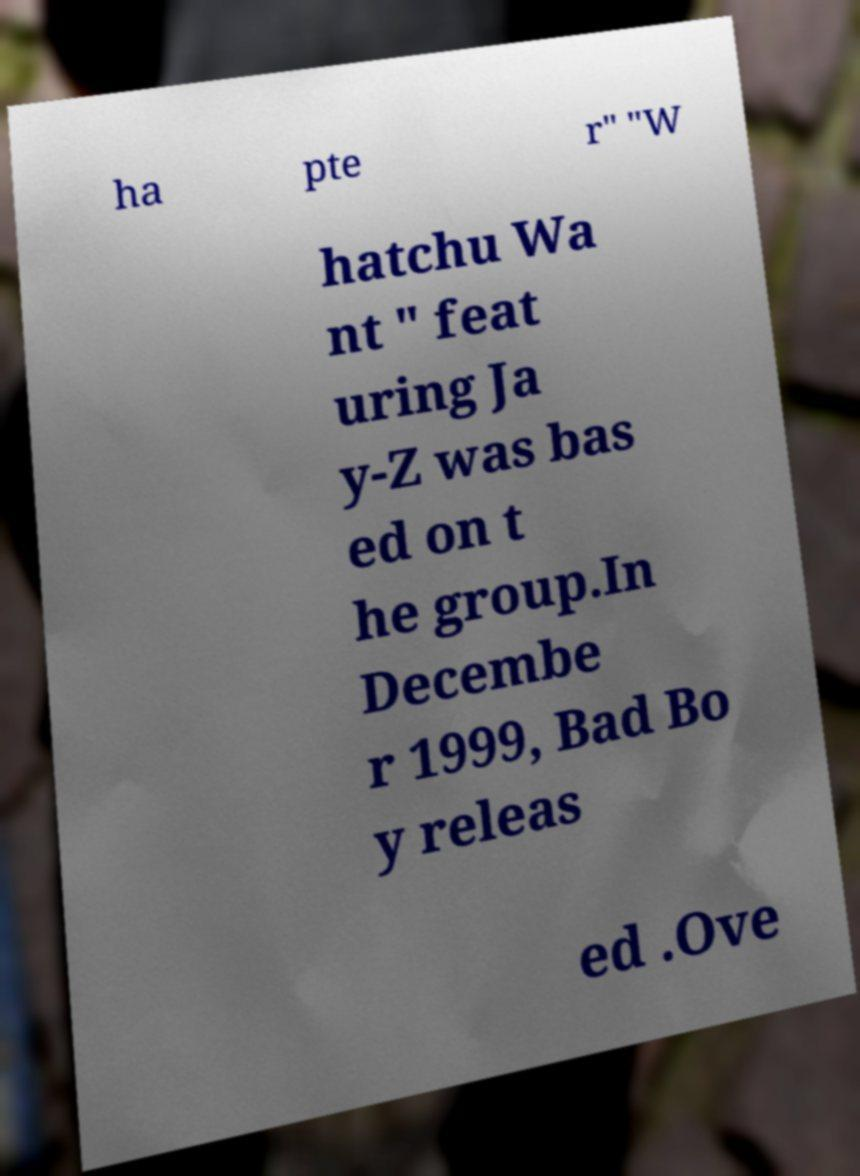What messages or text are displayed in this image? I need them in a readable, typed format. ha pte r" "W hatchu Wa nt " feat uring Ja y-Z was bas ed on t he group.In Decembe r 1999, Bad Bo y releas ed .Ove 